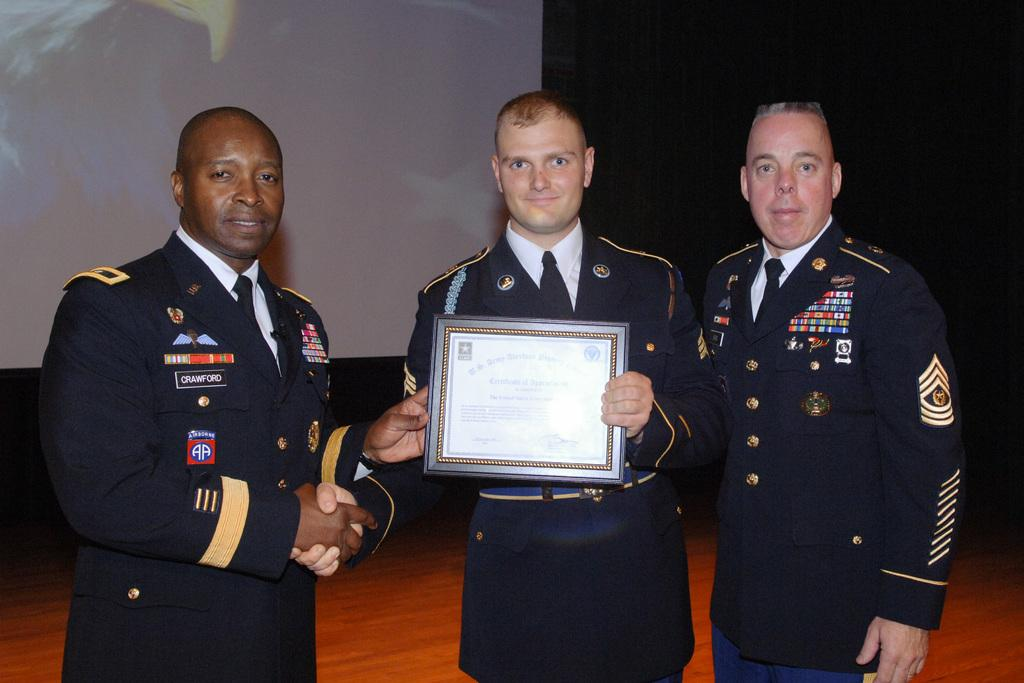How many people are present in the image? There are three people standing in the image. What are two of the people holding? Two people are holding a certificate. What can be seen in the background of the image? There is a projector screen in the background. What is the color of the background in the image? The background of the image is dark. What type of orange is being used to level the projector screen in the image? There is no orange or leveling activity present in the image. The projector screen is already set up in the background, and there is no indication of any orange being used for leveling purposes. 